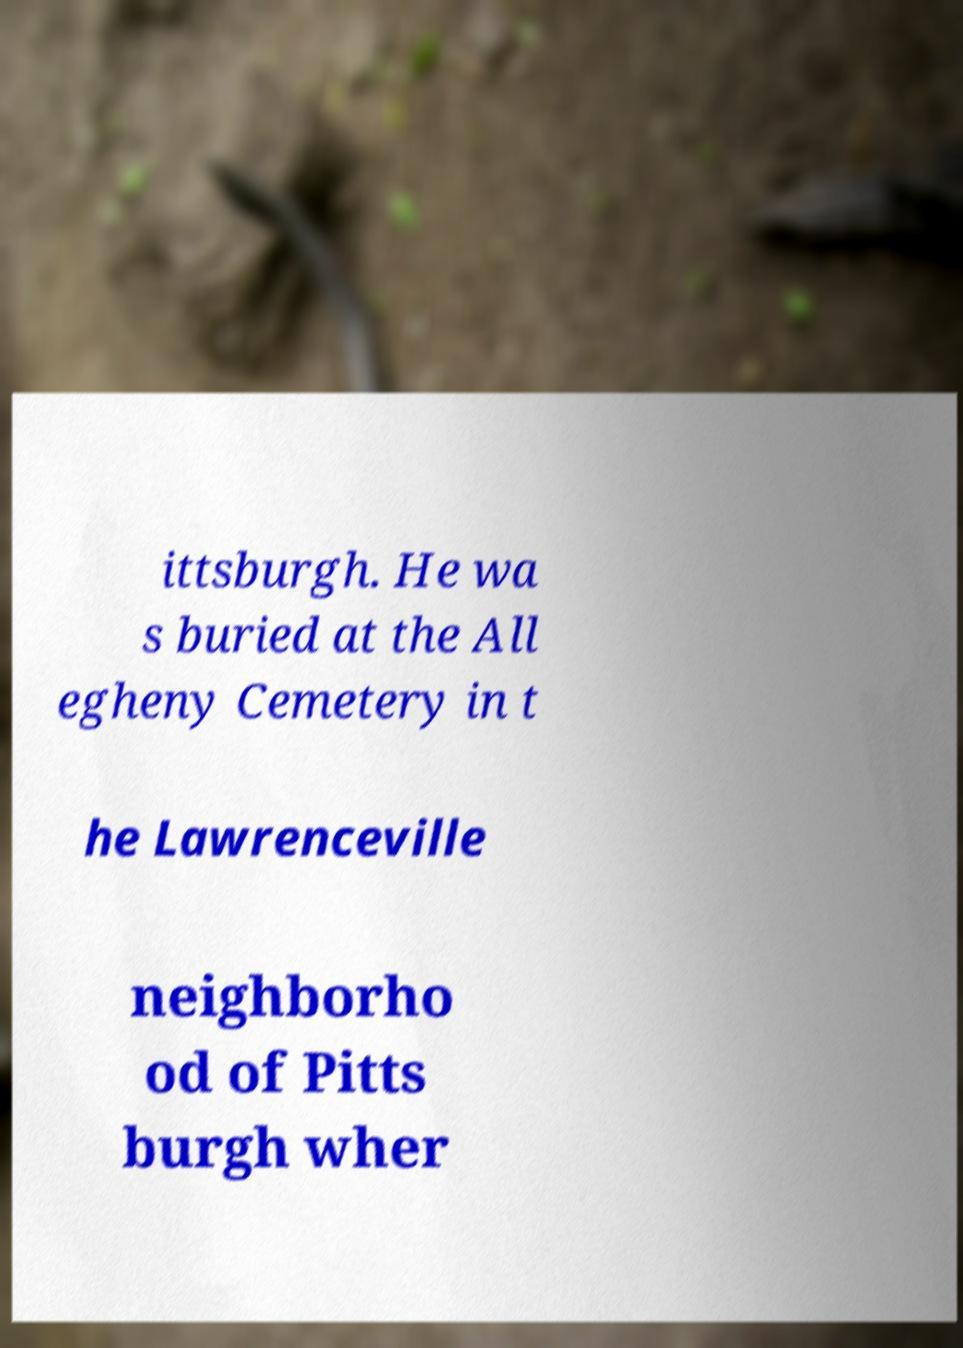Please read and relay the text visible in this image. What does it say? ittsburgh. He wa s buried at the All egheny Cemetery in t he Lawrenceville neighborho od of Pitts burgh wher 